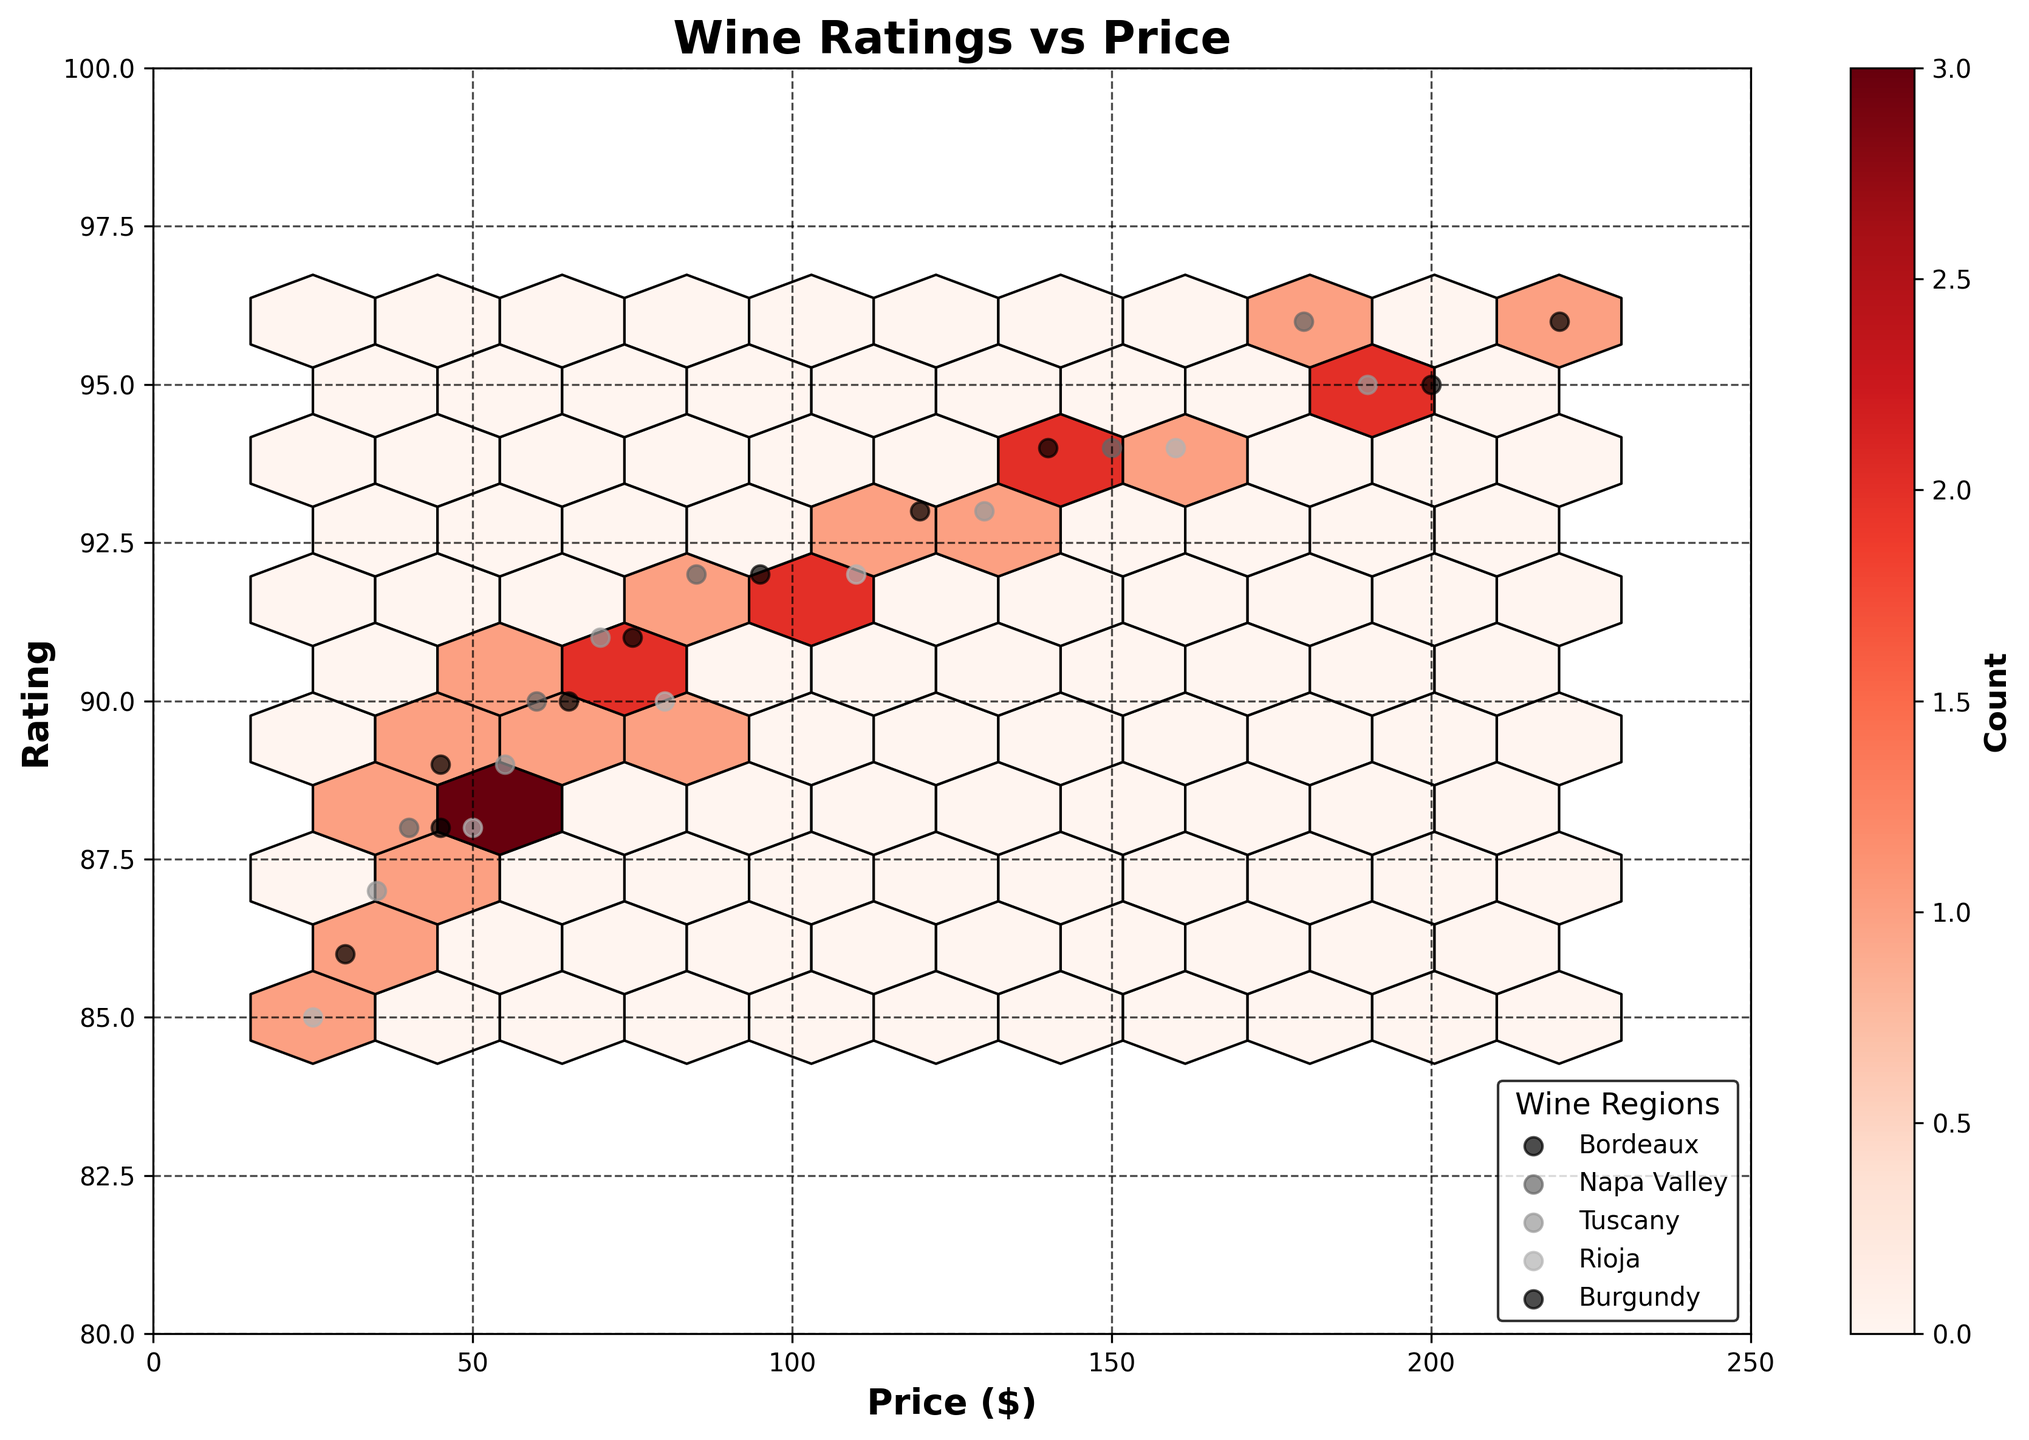What does the title of the figure indicate? The title of the figure provides an overview of what the graph represents. Here, it indicates that the plot shows the relationship between wine ratings and price.
Answer: Wine Ratings vs Price What are the labels on the x-axis and y-axis? The x-axis label represents the variable plotted horizontally, and the y-axis label represents the variable plotted vertically. In this plot, the x-axis label is "Price ($)," and the y-axis label is "Rating."
Answer: Price ($) and Rating What does the color bar represent in the figure? The color bar on the side of the plot represents the density or count of data points within each hexagonal bin. Darker hues indicate higher counts.
Answer: Count Which wine region has data points with the highest rating? By looking at the scatter points for each wine region, we can identify which region has the highest rating point. In this case, Burgundy and Napa Valley both have points with a rating of 96.
Answer: Burgundy and Napa Valley Which region has the wine with the lowest price? By identifying the region corresponding to the lowest price point on the x-axis, we can determine that Rioja has the lowest price at $25.
Answer: Rioja How many wine regions are plotted in the figure? Each unique legend label represents a distinct wine region. Counting these labels, we find there are five regions plotted.
Answer: Five Which price range has the highest density of wine ratings? To find this, we look at the hexagonal bins' color intensities on the x-axis. The highest density (darkest color) appears around the $50 to $100 range.
Answer: $50 to $100 Do wines with higher prices generally have higher ratings? Observing the overall trend from left (lower prices) to right (higher prices) and upwards (higher ratings), it shows that as prices increase, ratings also tend to increase, although not always linearly.
Answer: Yes Which region has the most uniformly distributed price points? By looking at the scatter plots, we find that Bordeaux appears to have the most evenly spread price points from low to high.
Answer: Bordeaux Is there an outlier in the figure, and which region does it belong to? An outlier is a data point that significantly differs from others. The point at $220 with a rating of 96 stands out and belongs to Burgundy.
Answer: Burgundy 